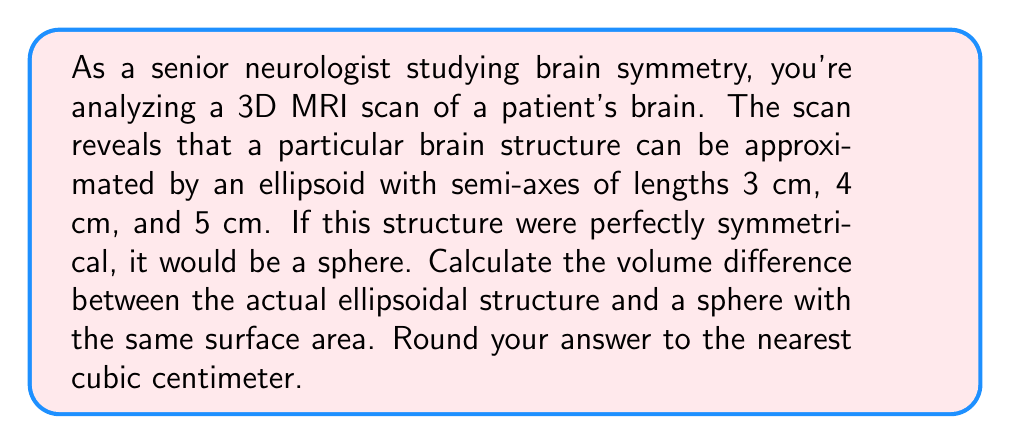Show me your answer to this math problem. To solve this problem, we'll follow these steps:

1) First, let's calculate the volume of the ellipsoid:
   The volume of an ellipsoid is given by the formula:
   $$V_e = \frac{4}{3}\pi abc$$
   where $a$, $b$, and $c$ are the semi-axes lengths.

   $$V_e = \frac{4}{3}\pi(3)(4)(5) = \frac{80}{3}\pi \approx 83.78 \text{ cm}^3$$

2) Next, we need to calculate the surface area of the ellipsoid:
   The surface area of an ellipsoid is approximated by:
   $$SA_e \approx 4\pi\left(\frac{(ab)^{1.6} + (ac)^{1.6} + (bc)^{1.6}}{3}\right)^{\frac{1}{1.6}}$$

   $$SA_e \approx 4\pi\left(\frac{(3\cdot4)^{1.6} + (3\cdot5)^{1.6} + (4\cdot5)^{1.6}}{3}\right)^{\frac{1}{1.6}}$$
   $$SA_e \approx 4\pi(13.33)^{\frac{1}{1.6}} \approx 188.71 \text{ cm}^2$$

3) Now, we need to find the radius of a sphere with this same surface area:
   The surface area of a sphere is $4\pi r^2$, so:
   $$188.71 = 4\pi r^2$$
   $$r^2 = \frac{188.71}{4\pi} \approx 15.01$$
   $$r \approx 3.87 \text{ cm}$$

4) Calculate the volume of this sphere:
   $$V_s = \frac{4}{3}\pi r^3 = \frac{4}{3}\pi(3.87)^3 \approx 243.24 \text{ cm}^3$$

5) Finally, calculate the difference in volume:
   $$\Delta V = V_s - V_e = 243.24 - 83.78 = 159.46 \text{ cm}^3$$

Rounding to the nearest cubic centimeter gives us 159 cm³.
Answer: 159 cm³ 